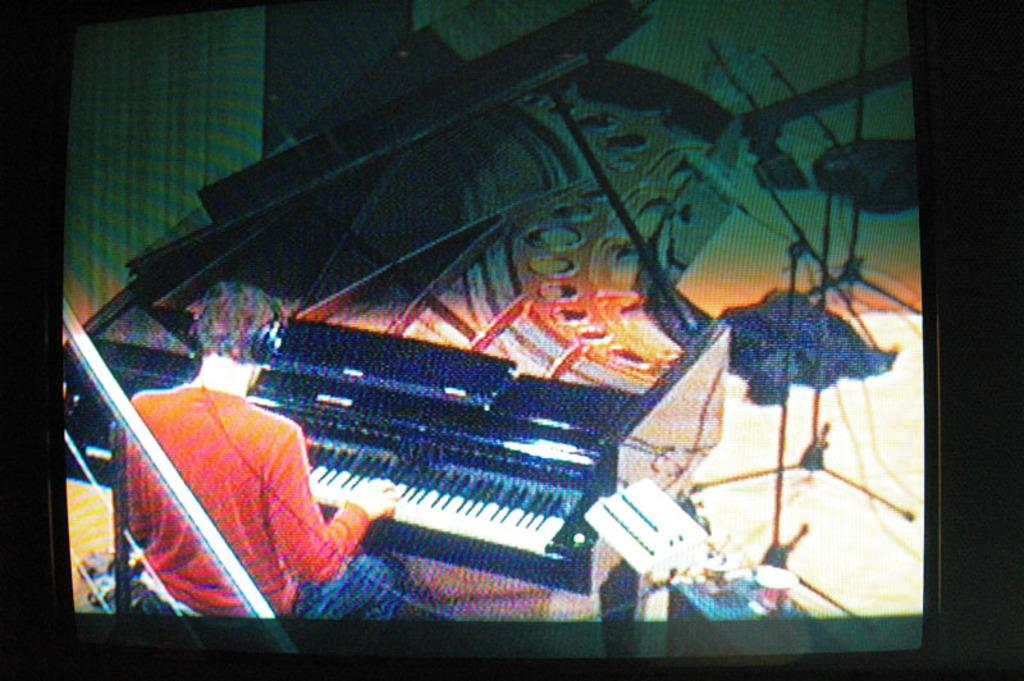What is the main subject of the image? The main subject of the image is a man. What is the man wearing in the image? The man is wearing a headset in the image. What is the man doing while wearing the headset? The man is sitting in a chair and playing the piano in the image. What can be seen in the background of the image? There is a picture-like scenery in the background of the image. What type of pets can be seen in the image? There are no pets visible in the image. How does the man's voice sound while playing the piano in the image? The image does not provide any information about the man's voice or how it sounds while playing the piano. 